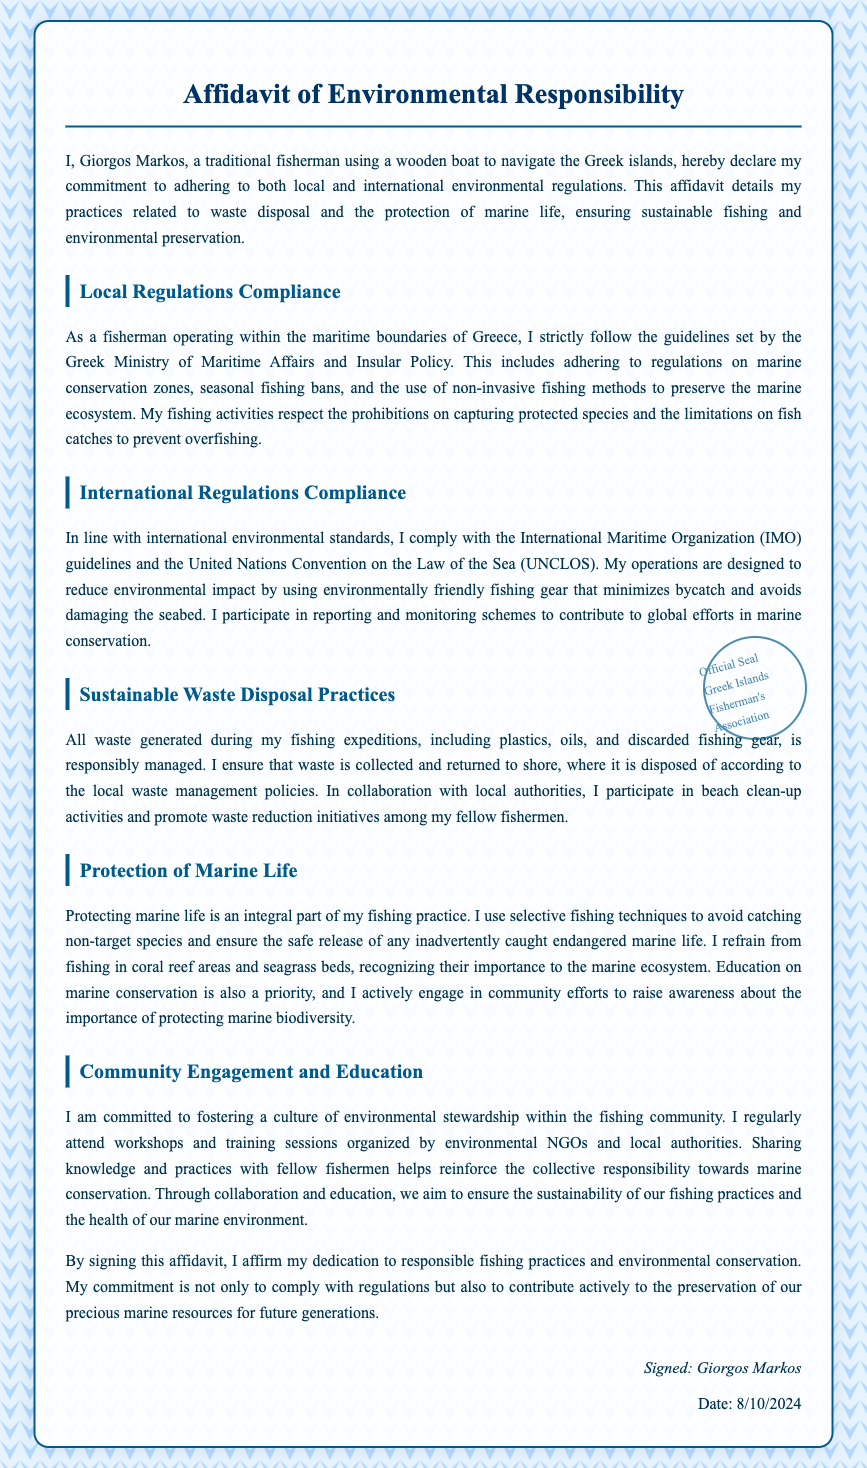What is the name of the person signing the affidavit? The affidavit begins with the declaration of the signer, providing their name.
Answer: Giorgos Markos What is the title of the document? The title clearly states the purpose of the document at the top.
Answer: Affidavit of Environmental Responsibility Who is the issuer of the official seal? The seal indicates the authority accompanying the affidavit, specifically for the fishing community.
Answer: Greek Islands Fisherman's Association What type of fishing methods does the signer adhere to? The document mentions specific practices that relate to the environment and fishing methods.
Answer: Non-invasive fishing methods Which ministry's guidelines does the signer follow? The document refers to the authority overseeing maritime activities in Greece.
Answer: Greek Ministry of Maritime Affairs and Insular Policy What is the significance of participating in beach clean-up activities? The document describes this practice as part of the waste management strategy and community involvement.
Answer: Marine conservation What type of fishing gear does the signer use? The affidavit states the environmental consideration taken into account when selecting fishing gear.
Answer: Environmentally friendly fishing gear What is one reason for not fishing in certain areas? The affidavit provides reasons related to the ecosystem and conservation practices.
Answer: Importance to the marine ecosystem What date was the affidavit signed? The signing date is dynamically generated in the document based on when it is viewed.
Answer: Current date (e.g., today's date) 